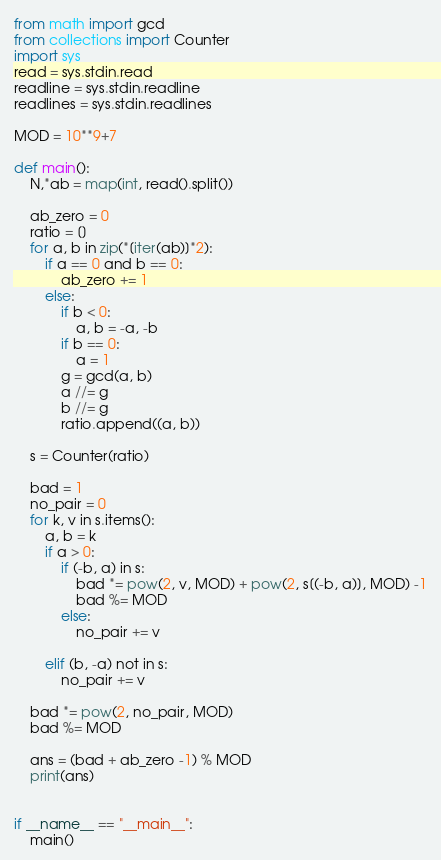<code> <loc_0><loc_0><loc_500><loc_500><_Python_>from math import gcd
from collections import Counter
import sys
read = sys.stdin.read
readline = sys.stdin.readline
readlines = sys.stdin.readlines

MOD = 10**9+7

def main():
    N,*ab = map(int, read().split())

    ab_zero = 0
    ratio = []
    for a, b in zip(*[iter(ab)]*2):
        if a == 0 and b == 0:
            ab_zero += 1
        else:
            if b < 0:
                a, b = -a, -b
            if b == 0:
                a = 1
            g = gcd(a, b)
            a //= g
            b //= g
            ratio.append((a, b))
    
    s = Counter(ratio)

    bad = 1
    no_pair = 0
    for k, v in s.items():
        a, b = k
        if a > 0:
            if (-b, a) in s:
                bad *= pow(2, v, MOD) + pow(2, s[(-b, a)], MOD) -1
                bad %= MOD
            else:
                no_pair += v
            
        elif (b, -a) not in s:
            no_pair += v

    bad *= pow(2, no_pair, MOD)
    bad %= MOD

    ans = (bad + ab_zero -1) % MOD
    print(ans)


if __name__ == "__main__":
    main()
</code> 